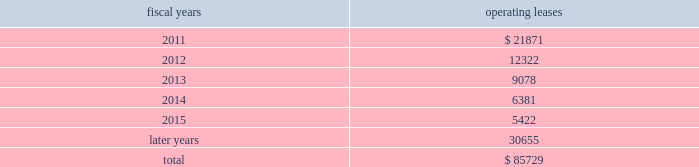The following is a schedule of future minimum rental payments required under long-term operating leases at october 30 , 2010 : fiscal years operating leases .
12 .
Commitments and contingencies from time to time in the ordinary course of the company 2019s business , various claims , charges and litigation are asserted or commenced against the company arising from , or related to , contractual matters , patents , trademarks , personal injury , environmental matters , product liability , insurance coverage and personnel and employment disputes .
As to such claims and litigation , the company can give no assurance that it will prevail .
The company does not believe that any current legal matters will have a material adverse effect on the company 2019s financial position , results of operations or cash flows .
13 .
Retirement plans the company and its subsidiaries have various savings and retirement plans covering substantially all employees .
The company maintains a defined contribution plan for the benefit of its eligible u.s .
Employees .
This plan provides for company contributions of up to 5% ( 5 % ) of each participant 2019s total eligible compensation .
In addition , the company contributes an amount equal to each participant 2019s pre-tax contribution , if any , up to a maximum of 3% ( 3 % ) of each participant 2019s total eligible compensation .
The total expense related to the defined contribution plan for u.s .
Employees was $ 20.5 million in fiscal 2010 , $ 21.5 million in fiscal 2009 and $ 22.6 million in fiscal 2008 .
The company also has various defined benefit pension and other retirement plans for certain non-u.s .
Employees that are consistent with local statutory requirements and practices .
The total expense related to the various defined benefit pension and other retirement plans for certain non-u.s .
Employees was $ 11.7 million in fiscal 2010 , $ 10.9 million in fiscal 2009 and $ 13.9 million in fiscal 2008 .
During fiscal 2009 , the measurement date of the plan 2019s funded status was changed from september 30 to the company 2019s fiscal year end .
Non-u.s .
Plan disclosures the company 2019s funding policy for its foreign defined benefit pension plans is consistent with the local requirements of each country .
The plans 2019 assets consist primarily of u.s .
And non-u.s .
Equity securities , bonds , property and cash .
The benefit obligations and related assets under these plans have been measured at october 30 , 2010 and october 31 , 2009 .
Analog devices , inc .
Notes to consolidated financial statements 2014 ( continued ) .
What is the percentage change in the total expense related to the defined contribution plan for u.s employees in 2010? 
Computations: ((20.5 - 21.5) / 21.5)
Answer: -0.04651. 